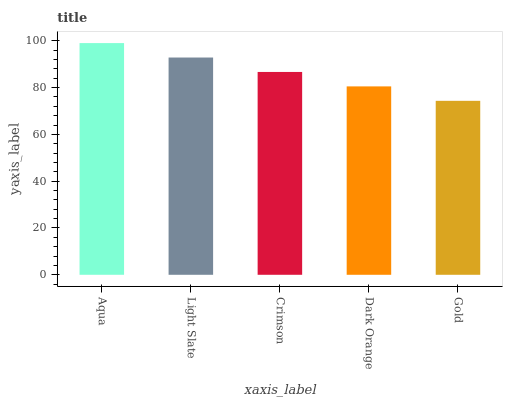Is Light Slate the minimum?
Answer yes or no. No. Is Light Slate the maximum?
Answer yes or no. No. Is Aqua greater than Light Slate?
Answer yes or no. Yes. Is Light Slate less than Aqua?
Answer yes or no. Yes. Is Light Slate greater than Aqua?
Answer yes or no. No. Is Aqua less than Light Slate?
Answer yes or no. No. Is Crimson the high median?
Answer yes or no. Yes. Is Crimson the low median?
Answer yes or no. Yes. Is Dark Orange the high median?
Answer yes or no. No. Is Aqua the low median?
Answer yes or no. No. 